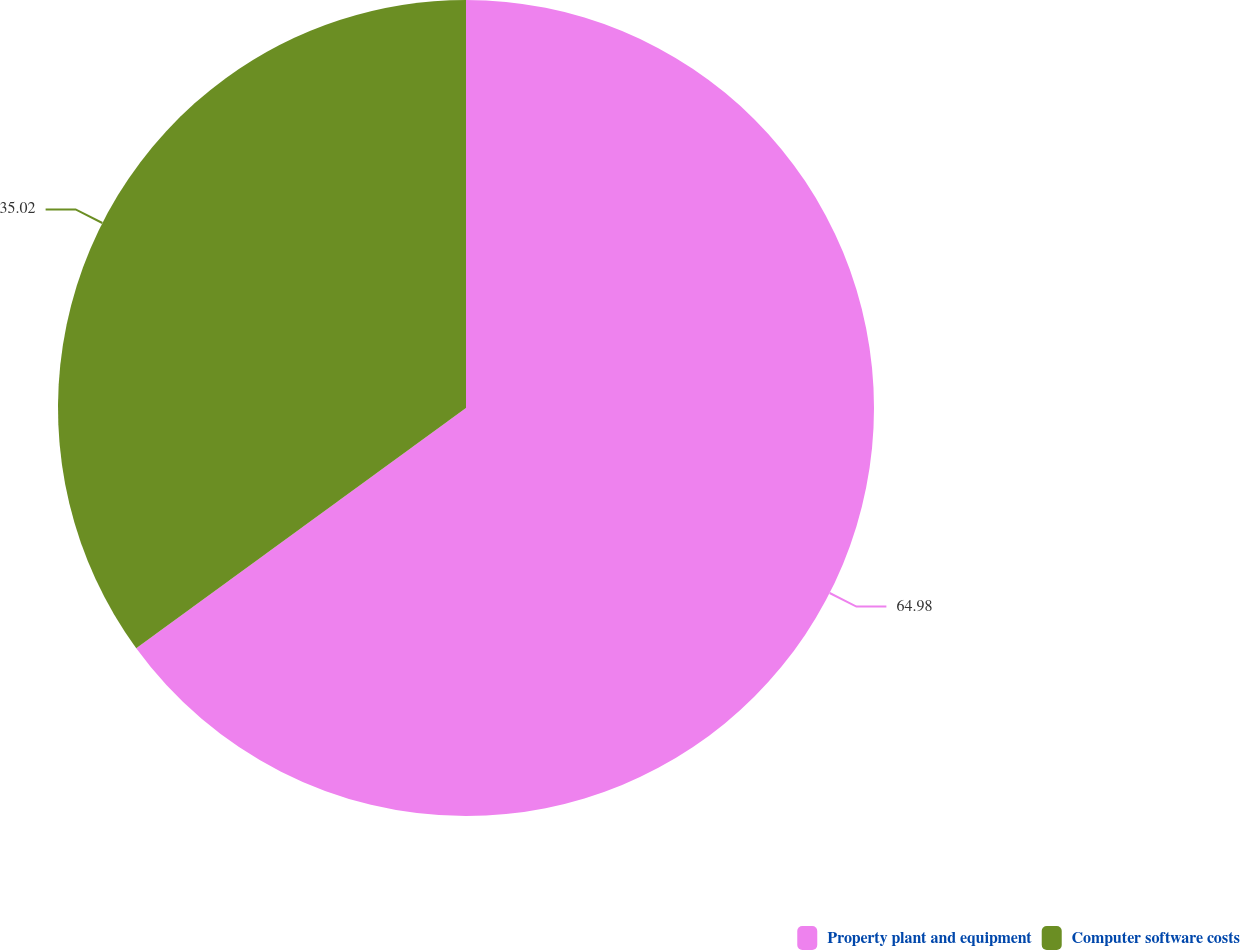Convert chart to OTSL. <chart><loc_0><loc_0><loc_500><loc_500><pie_chart><fcel>Property plant and equipment<fcel>Computer software costs<nl><fcel>64.98%<fcel>35.02%<nl></chart> 